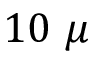<formula> <loc_0><loc_0><loc_500><loc_500>1 0 \mu</formula> 